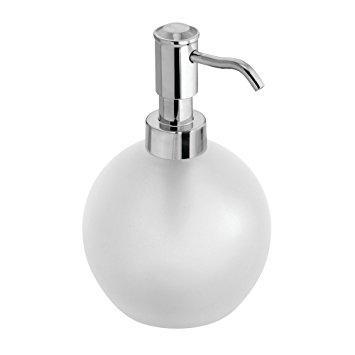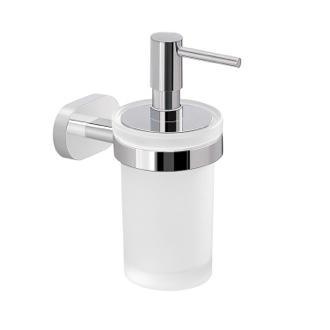The first image is the image on the left, the second image is the image on the right. Evaluate the accuracy of this statement regarding the images: "There are two white plastic dispenser bottles.". Is it true? Answer yes or no. Yes. The first image is the image on the left, the second image is the image on the right. Considering the images on both sides, is "One image shows a dispenser with a right-turned nozzle that mounts on the wall with a chrome band around it, and the other image shows a free-standing pump-top dispenser with a chrome top." valid? Answer yes or no. Yes. 